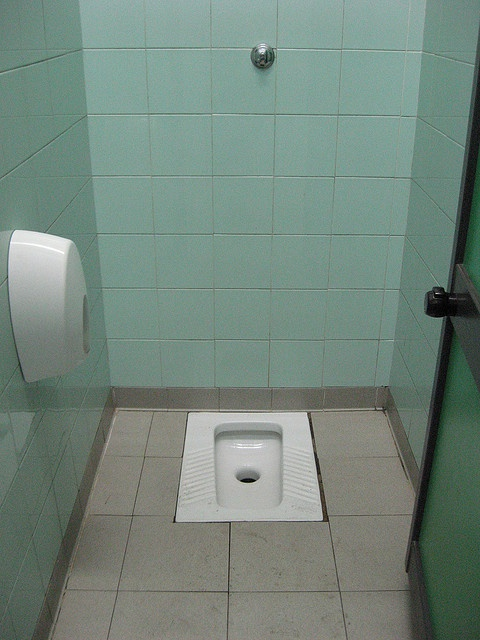Describe the objects in this image and their specific colors. I can see a toilet in gray, darkgray, and lightgray tones in this image. 